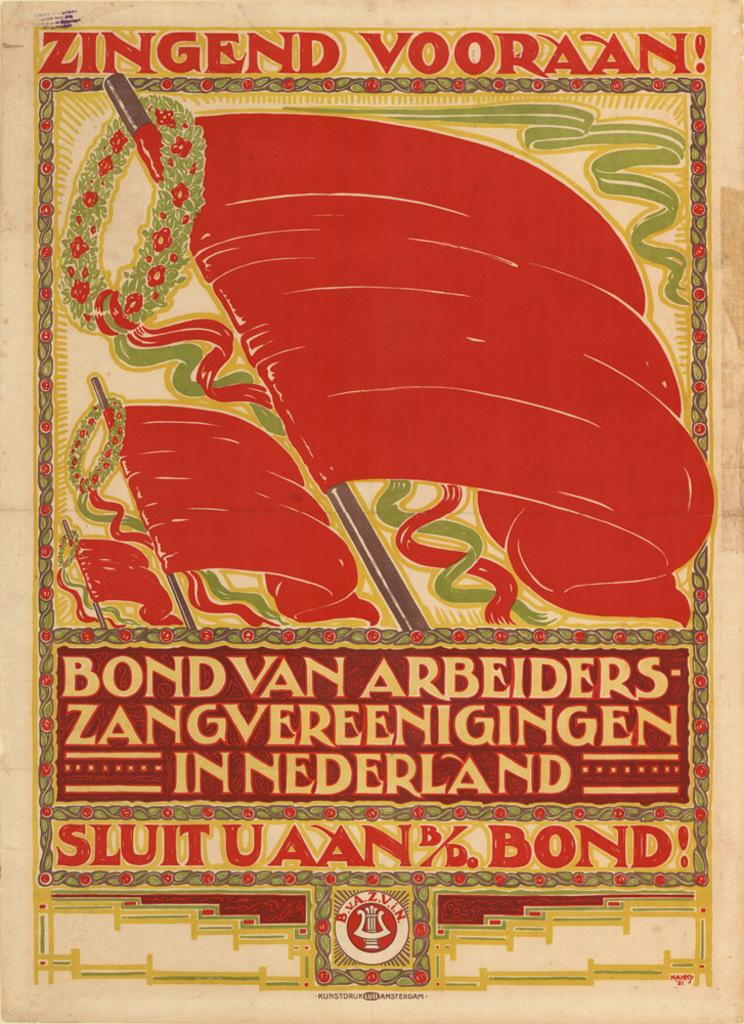Provide a one-sentence caption for the provided image. A colorful poster in orange, green and yellow with Sluituaan bond on the bottom. 